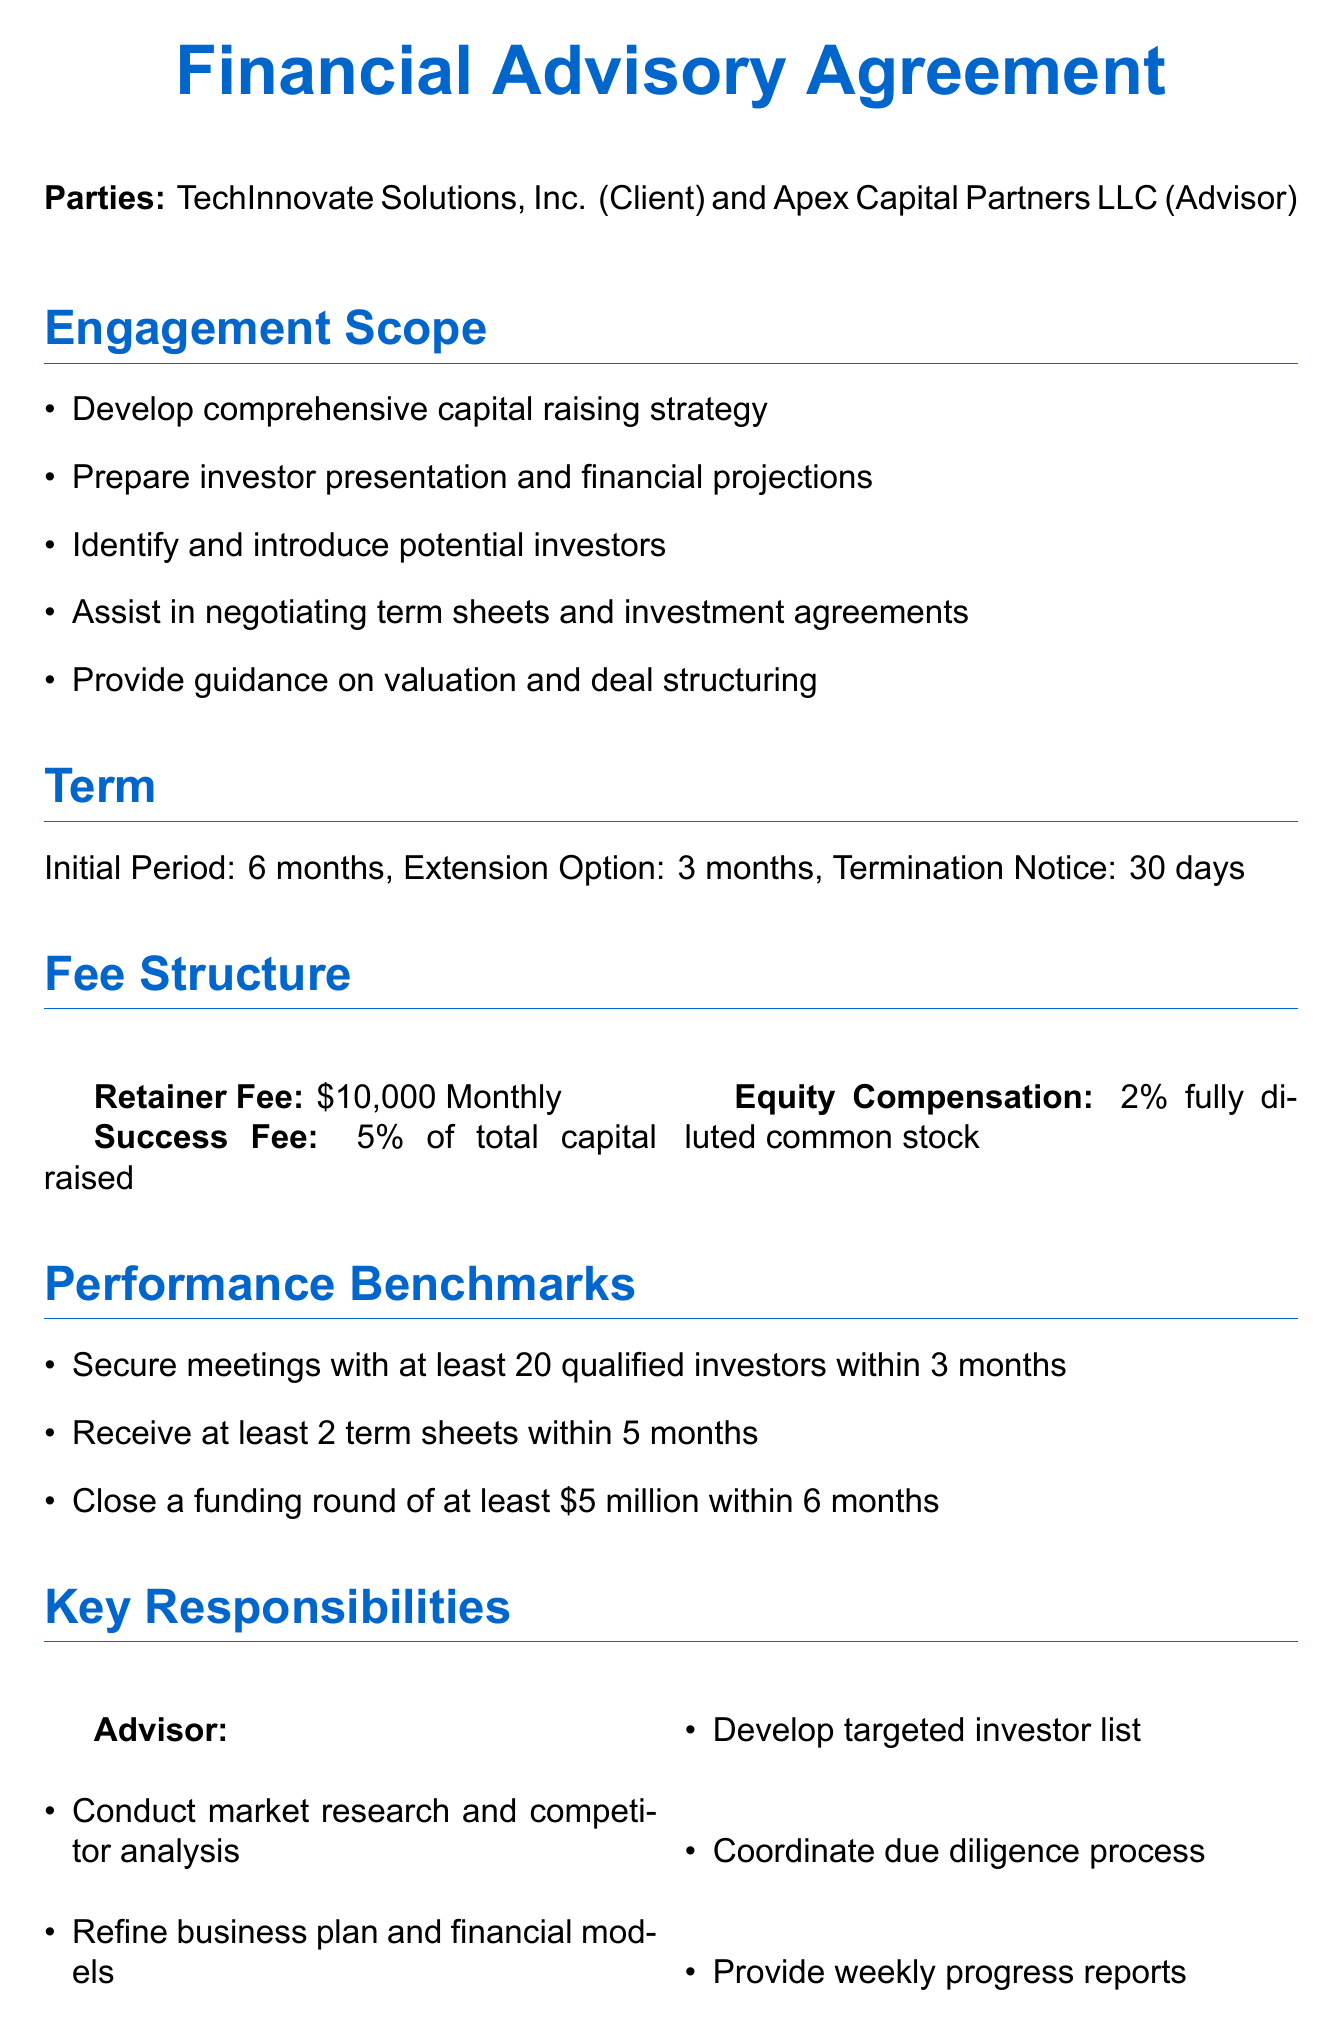What is the name of the client? The client's name is specified in the document under "Parties."
Answer: TechInnovate Solutions, Inc What is the initial period of the engagement? The initial period is mentioned in the "Term" section.
Answer: 6 months What is the percentage of the success fee? The success fee percentage is detailed in the "Fee Structure" section.
Answer: 5% How many qualified investors must be met within 3 months? This milestone is found in the "Performance Benchmarks" section.
Answer: 20 What is the equity compensation amount? The equity compensation is outlined in the "Fee Structure" section.
Answer: 2% Who is the CEO of the client company? The CEO's name is provided in the "Key Contacts" section.
Answer: Sarah Chen What is the duration of the confidentiality clause? The duration is specified in the "Confidentiality" section of the document.
Answer: 3 years Which city is mentioned for dispute resolution? The location for dispute resolution is listed under the "Dispute Resolution" section.
Answer: San Francisco What type of stock is the equity compensation? The type of stock is described in the "Fee Structure" section.
Answer: Fully diluted common stock 